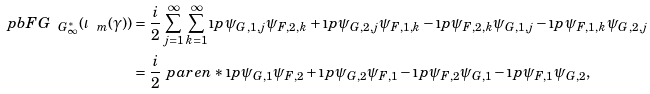<formula> <loc_0><loc_0><loc_500><loc_500>\ p b { F } { G } _ { \ G _ { \infty } ^ { * } } ( \iota _ { \ m } ( \gamma ) ) & = \frac { i } { 2 } \sum _ { j = 1 } ^ { \infty } \sum _ { k = 1 } ^ { \infty } \i p { \psi _ { G , 1 , j } } { \psi _ { F , 2 , k } } + \i p { \psi _ { G , 2 , j } } { \psi _ { F , 1 , k } } - \i p { \psi _ { F , 2 , k } } { \psi _ { G , 1 , j } } - \i p { \psi _ { F , 1 , k } } { \psi _ { G , 2 , j } } \\ & = \frac { i } { 2 } \ p a r e n * { \i p { \psi _ { G , 1 } } { \psi _ { F , 2 } } + \i p { \psi _ { G , 2 } } { \psi _ { F , 1 } } - \i p { \psi _ { F , 2 } } { \psi _ { G , 1 } } - \i p { \psi _ { F , 1 } } { \psi _ { G , 2 } } } ,</formula> 